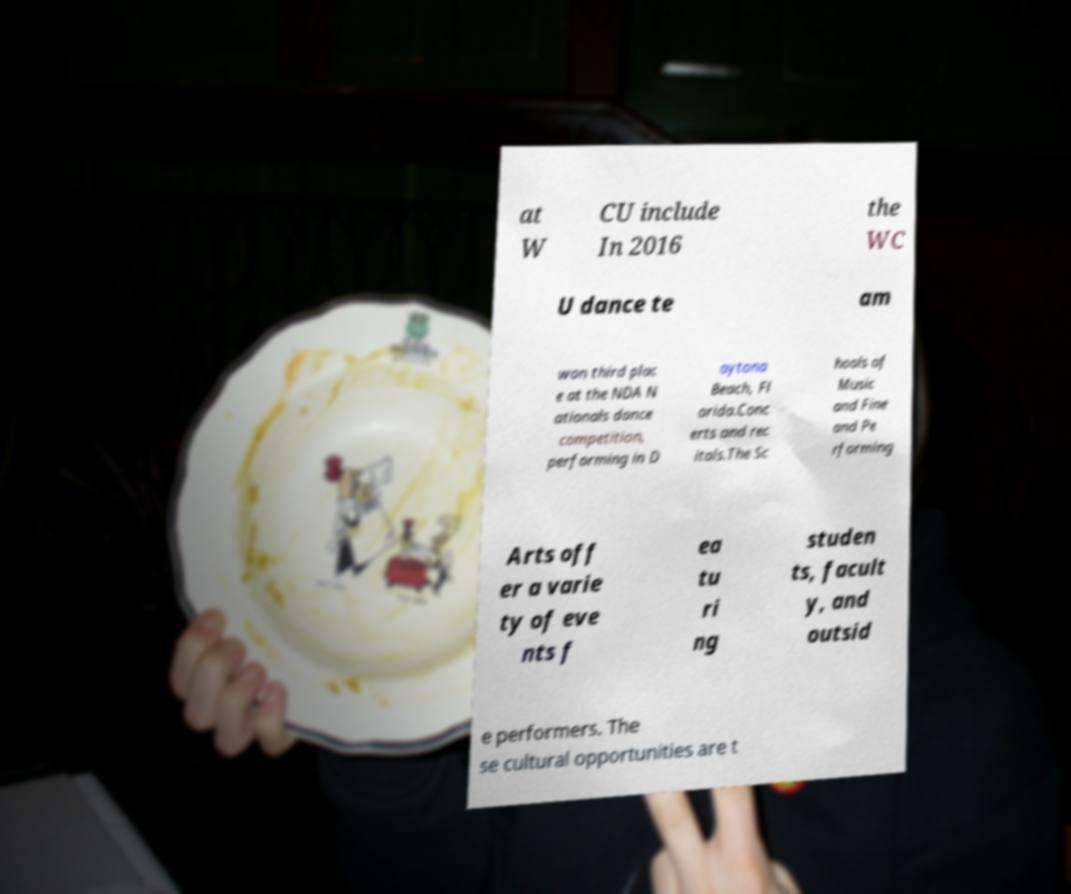Could you extract and type out the text from this image? at W CU include In 2016 the WC U dance te am won third plac e at the NDA N ationals dance competition, performing in D aytona Beach, Fl orida.Conc erts and rec itals.The Sc hools of Music and Fine and Pe rforming Arts off er a varie ty of eve nts f ea tu ri ng studen ts, facult y, and outsid e performers. The se cultural opportunities are t 